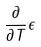<formula> <loc_0><loc_0><loc_500><loc_500>\frac { \partial } { \partial T } \epsilon</formula> 